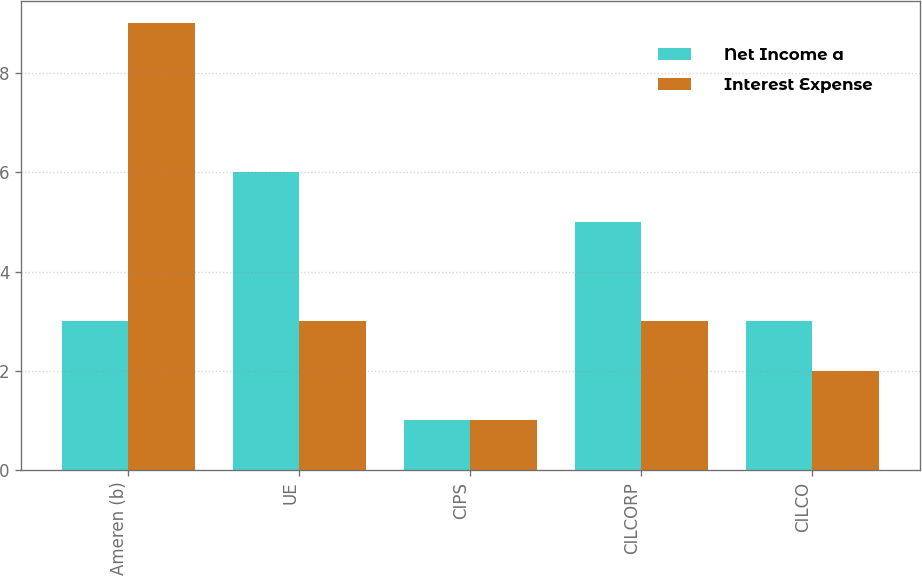Convert chart. <chart><loc_0><loc_0><loc_500><loc_500><stacked_bar_chart><ecel><fcel>Ameren (b)<fcel>UE<fcel>CIPS<fcel>CILCORP<fcel>CILCO<nl><fcel>Net Income a<fcel>3<fcel>6<fcel>1<fcel>5<fcel>3<nl><fcel>Interest Expense<fcel>9<fcel>3<fcel>1<fcel>3<fcel>2<nl></chart> 